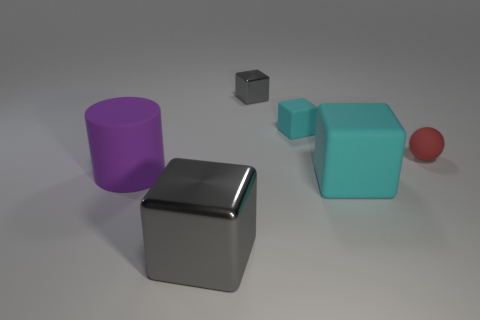Subtract all big shiny blocks. How many blocks are left? 3 Add 2 big gray cubes. How many objects exist? 8 Subtract all balls. How many objects are left? 5 Subtract all cyan cubes. How many cubes are left? 2 Subtract 3 blocks. How many blocks are left? 1 Subtract all cyan spheres. How many cyan cubes are left? 2 Add 4 large cylinders. How many large cylinders are left? 5 Add 2 small brown blocks. How many small brown blocks exist? 2 Subtract 0 yellow spheres. How many objects are left? 6 Subtract all green blocks. Subtract all brown cylinders. How many blocks are left? 4 